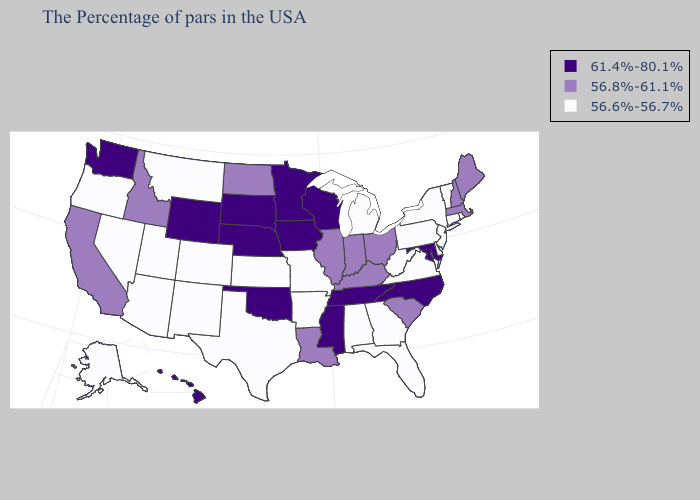What is the value of New Mexico?
Quick response, please. 56.6%-56.7%. Does the map have missing data?
Be succinct. No. Does Kansas have a lower value than Vermont?
Give a very brief answer. No. What is the value of Arkansas?
Quick response, please. 56.6%-56.7%. Name the states that have a value in the range 56.6%-56.7%?
Be succinct. Rhode Island, Vermont, Connecticut, New York, New Jersey, Delaware, Pennsylvania, Virginia, West Virginia, Florida, Georgia, Michigan, Alabama, Missouri, Arkansas, Kansas, Texas, Colorado, New Mexico, Utah, Montana, Arizona, Nevada, Oregon, Alaska. Name the states that have a value in the range 56.8%-61.1%?
Give a very brief answer. Maine, Massachusetts, New Hampshire, South Carolina, Ohio, Kentucky, Indiana, Illinois, Louisiana, North Dakota, Idaho, California. Among the states that border California , which have the lowest value?
Write a very short answer. Arizona, Nevada, Oregon. Which states have the highest value in the USA?
Concise answer only. Maryland, North Carolina, Tennessee, Wisconsin, Mississippi, Minnesota, Iowa, Nebraska, Oklahoma, South Dakota, Wyoming, Washington, Hawaii. What is the value of Michigan?
Quick response, please. 56.6%-56.7%. Does North Dakota have a higher value than Vermont?
Keep it brief. Yes. What is the value of Indiana?
Answer briefly. 56.8%-61.1%. Name the states that have a value in the range 56.6%-56.7%?
Keep it brief. Rhode Island, Vermont, Connecticut, New York, New Jersey, Delaware, Pennsylvania, Virginia, West Virginia, Florida, Georgia, Michigan, Alabama, Missouri, Arkansas, Kansas, Texas, Colorado, New Mexico, Utah, Montana, Arizona, Nevada, Oregon, Alaska. Is the legend a continuous bar?
Keep it brief. No. Name the states that have a value in the range 56.8%-61.1%?
Be succinct. Maine, Massachusetts, New Hampshire, South Carolina, Ohio, Kentucky, Indiana, Illinois, Louisiana, North Dakota, Idaho, California. Does the map have missing data?
Write a very short answer. No. 